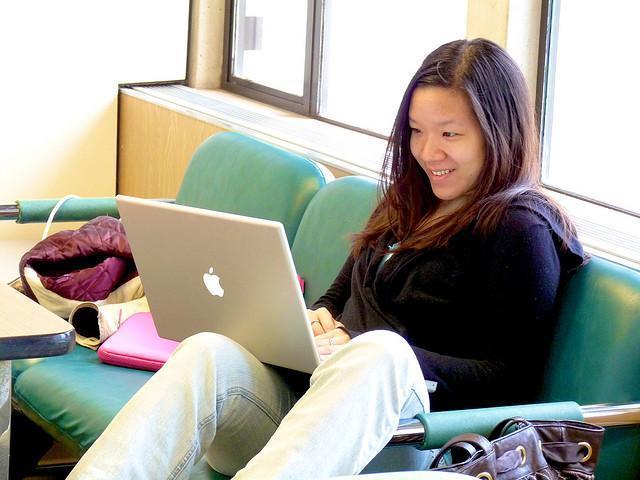Is this affirmation: "The couch is beneath the person." correct?
Answer yes or no. Yes. Does the caption "The person is at the right side of the couch." correctly depict the image?
Answer yes or no. Yes. 